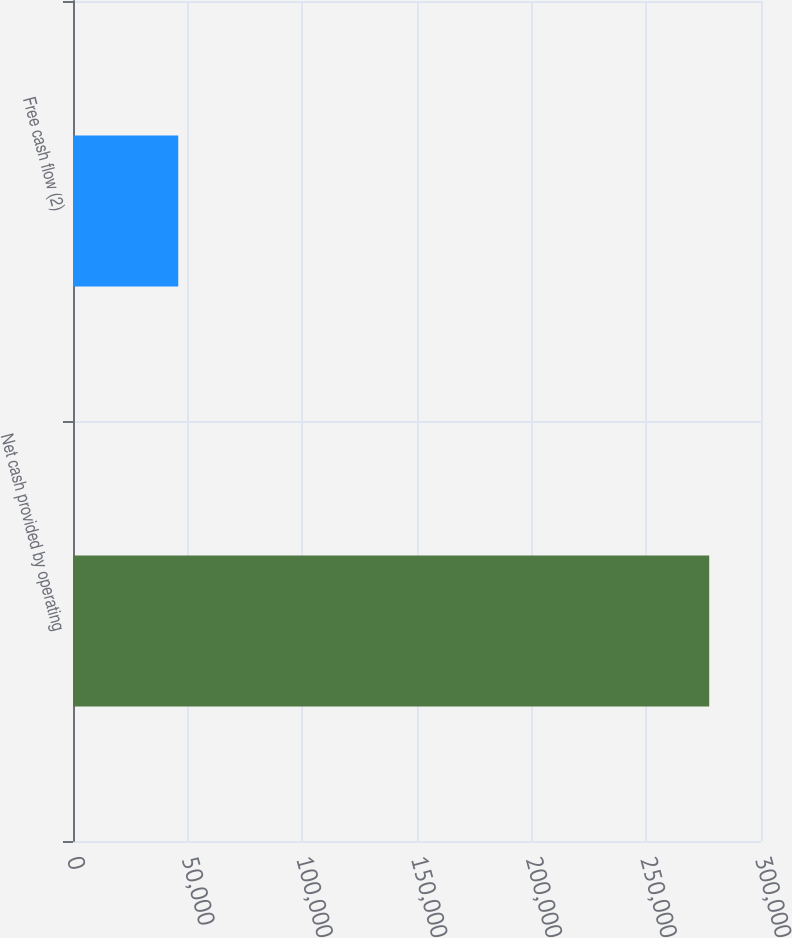<chart> <loc_0><loc_0><loc_500><loc_500><bar_chart><fcel>Net cash provided by operating<fcel>Free cash flow (2)<nl><fcel>277420<fcel>45889<nl></chart> 